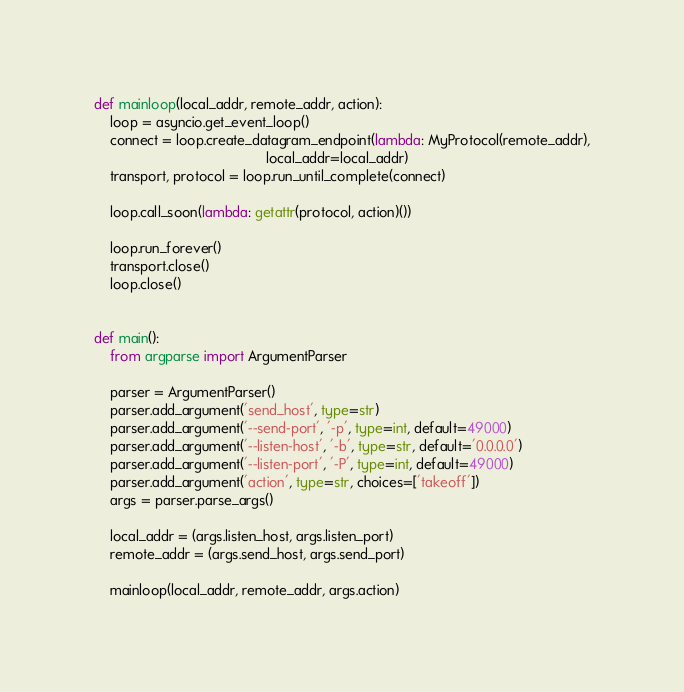<code> <loc_0><loc_0><loc_500><loc_500><_Python_>
def mainloop(local_addr, remote_addr, action):
    loop = asyncio.get_event_loop()
    connect = loop.create_datagram_endpoint(lambda: MyProtocol(remote_addr),
                                            local_addr=local_addr)
    transport, protocol = loop.run_until_complete(connect)

    loop.call_soon(lambda: getattr(protocol, action)())

    loop.run_forever()
    transport.close()
    loop.close()


def main():
    from argparse import ArgumentParser

    parser = ArgumentParser()
    parser.add_argument('send_host', type=str)
    parser.add_argument('--send-port', '-p', type=int, default=49000)
    parser.add_argument('--listen-host', '-b', type=str, default='0.0.0.0')
    parser.add_argument('--listen-port', '-P', type=int, default=49000)
    parser.add_argument('action', type=str, choices=['takeoff'])
    args = parser.parse_args()

    local_addr = (args.listen_host, args.listen_port)
    remote_addr = (args.send_host, args.send_port)

    mainloop(local_addr, remote_addr, args.action)
</code> 